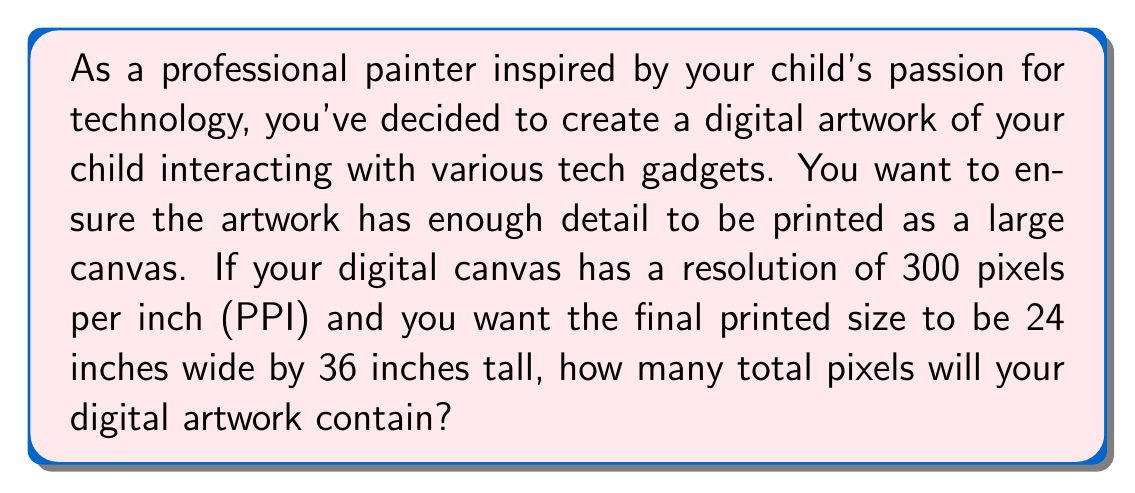Teach me how to tackle this problem. To solve this problem, we need to follow these steps:

1. Determine the number of pixels in the width:
   $$\text{Width in pixels} = \text{Width in inches} \times \text{Pixels per inch}$$
   $$\text{Width in pixels} = 24 \times 300 = 7,200 \text{ pixels}$$

2. Determine the number of pixels in the height:
   $$\text{Height in pixels} = \text{Height in inches} \times \text{Pixels per inch}$$
   $$\text{Height in pixels} = 36 \times 300 = 10,800 \text{ pixels}$$

3. Calculate the total number of pixels by multiplying the width and height in pixels:
   $$\text{Total pixels} = \text{Width in pixels} \times \text{Height in pixels}$$
   $$\text{Total pixels} = 7,200 \times 10,800 = 77,760,000 \text{ pixels}$$

This calculation gives us the total number of pixels in the digital artwork, which is important for understanding the level of detail and file size of the digital painting.
Answer: The digital artwork will contain $77,760,000$ pixels. 